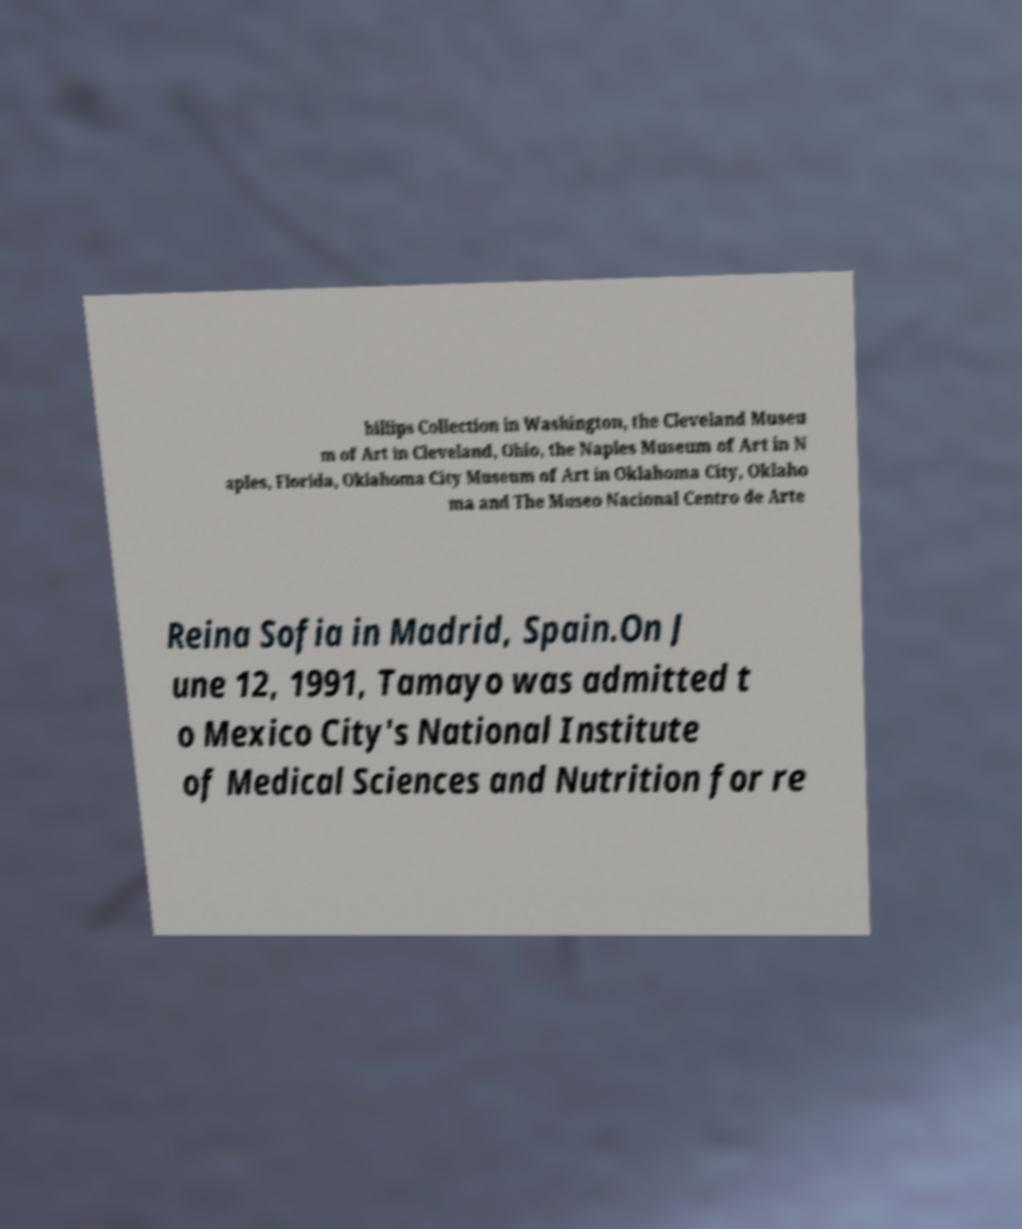What messages or text are displayed in this image? I need them in a readable, typed format. hillips Collection in Washington, the Cleveland Museu m of Art in Cleveland, Ohio, the Naples Museum of Art in N aples, Florida, Oklahoma City Museum of Art in Oklahoma City, Oklaho ma and The Museo Nacional Centro de Arte Reina Sofia in Madrid, Spain.On J une 12, 1991, Tamayo was admitted t o Mexico City's National Institute of Medical Sciences and Nutrition for re 